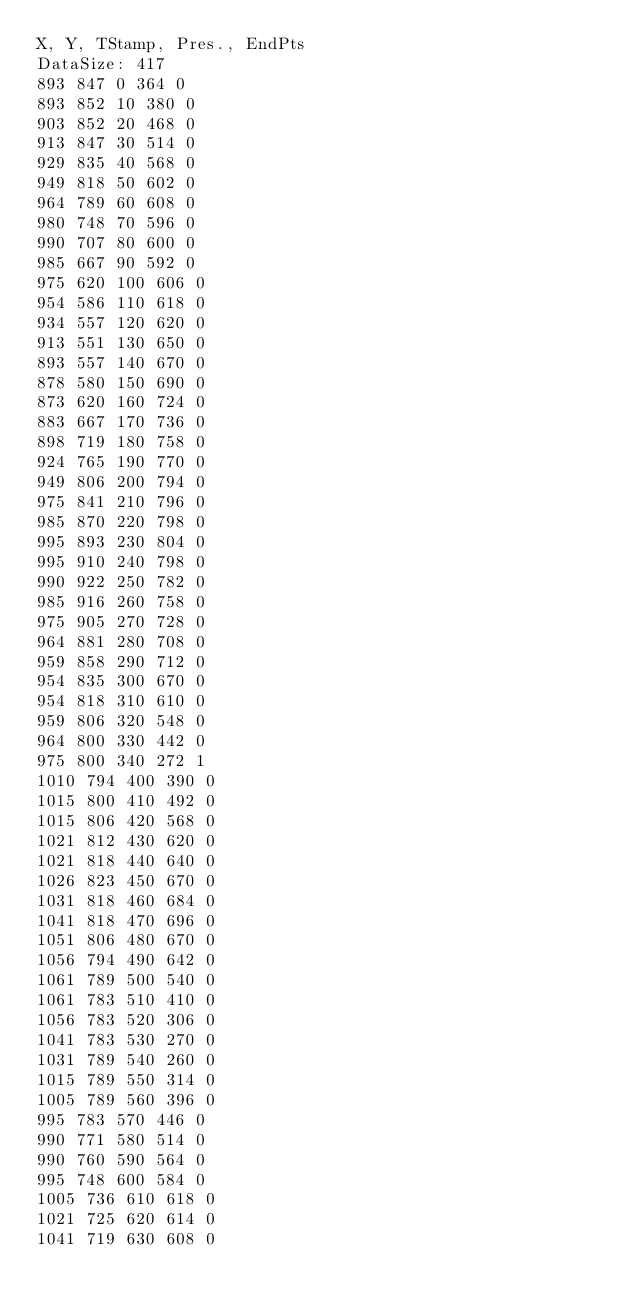<code> <loc_0><loc_0><loc_500><loc_500><_SML_>X, Y, TStamp, Pres., EndPts
DataSize: 417
893 847 0 364 0
893 852 10 380 0
903 852 20 468 0
913 847 30 514 0
929 835 40 568 0
949 818 50 602 0
964 789 60 608 0
980 748 70 596 0
990 707 80 600 0
985 667 90 592 0
975 620 100 606 0
954 586 110 618 0
934 557 120 620 0
913 551 130 650 0
893 557 140 670 0
878 580 150 690 0
873 620 160 724 0
883 667 170 736 0
898 719 180 758 0
924 765 190 770 0
949 806 200 794 0
975 841 210 796 0
985 870 220 798 0
995 893 230 804 0
995 910 240 798 0
990 922 250 782 0
985 916 260 758 0
975 905 270 728 0
964 881 280 708 0
959 858 290 712 0
954 835 300 670 0
954 818 310 610 0
959 806 320 548 0
964 800 330 442 0
975 800 340 272 1
1010 794 400 390 0
1015 800 410 492 0
1015 806 420 568 0
1021 812 430 620 0
1021 818 440 640 0
1026 823 450 670 0
1031 818 460 684 0
1041 818 470 696 0
1051 806 480 670 0
1056 794 490 642 0
1061 789 500 540 0
1061 783 510 410 0
1056 783 520 306 0
1041 783 530 270 0
1031 789 540 260 0
1015 789 550 314 0
1005 789 560 396 0
995 783 570 446 0
990 771 580 514 0
990 760 590 564 0
995 748 600 584 0
1005 736 610 618 0
1021 725 620 614 0
1041 719 630 608 0</code> 